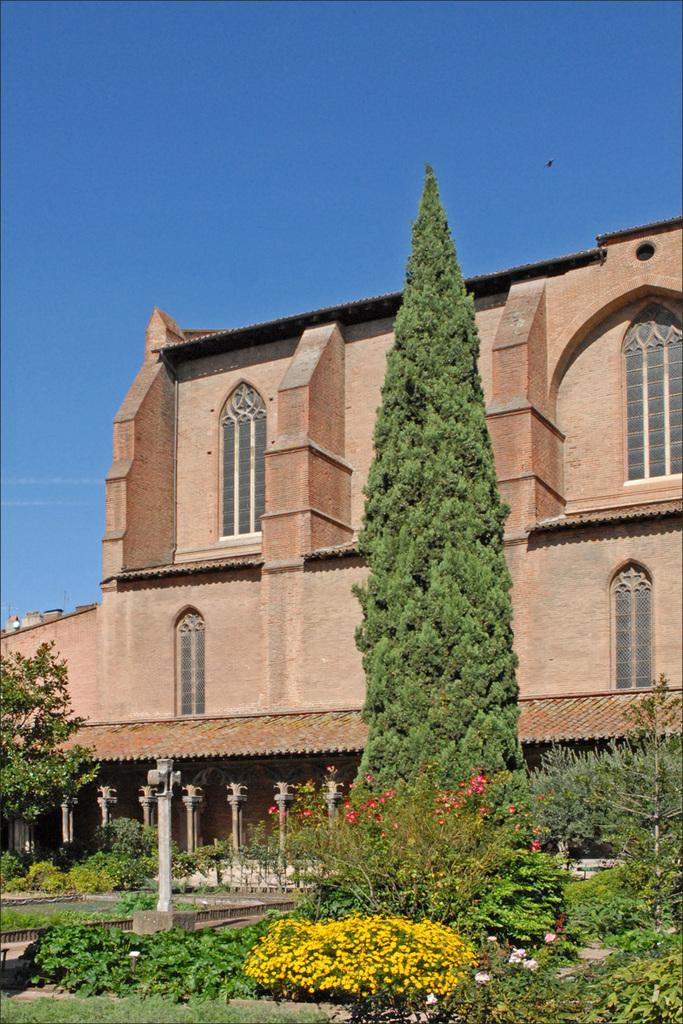What type of structure is visible in the image? There is a building in the image. What can be seen in front of the building? There are poles, plants, flowers, and trees in front of the building. What is visible at the top of the image? The sky is visible at the top of the image. What type of mint is being distributed by the donkey in the image? There is no donkey or mint present in the image. 